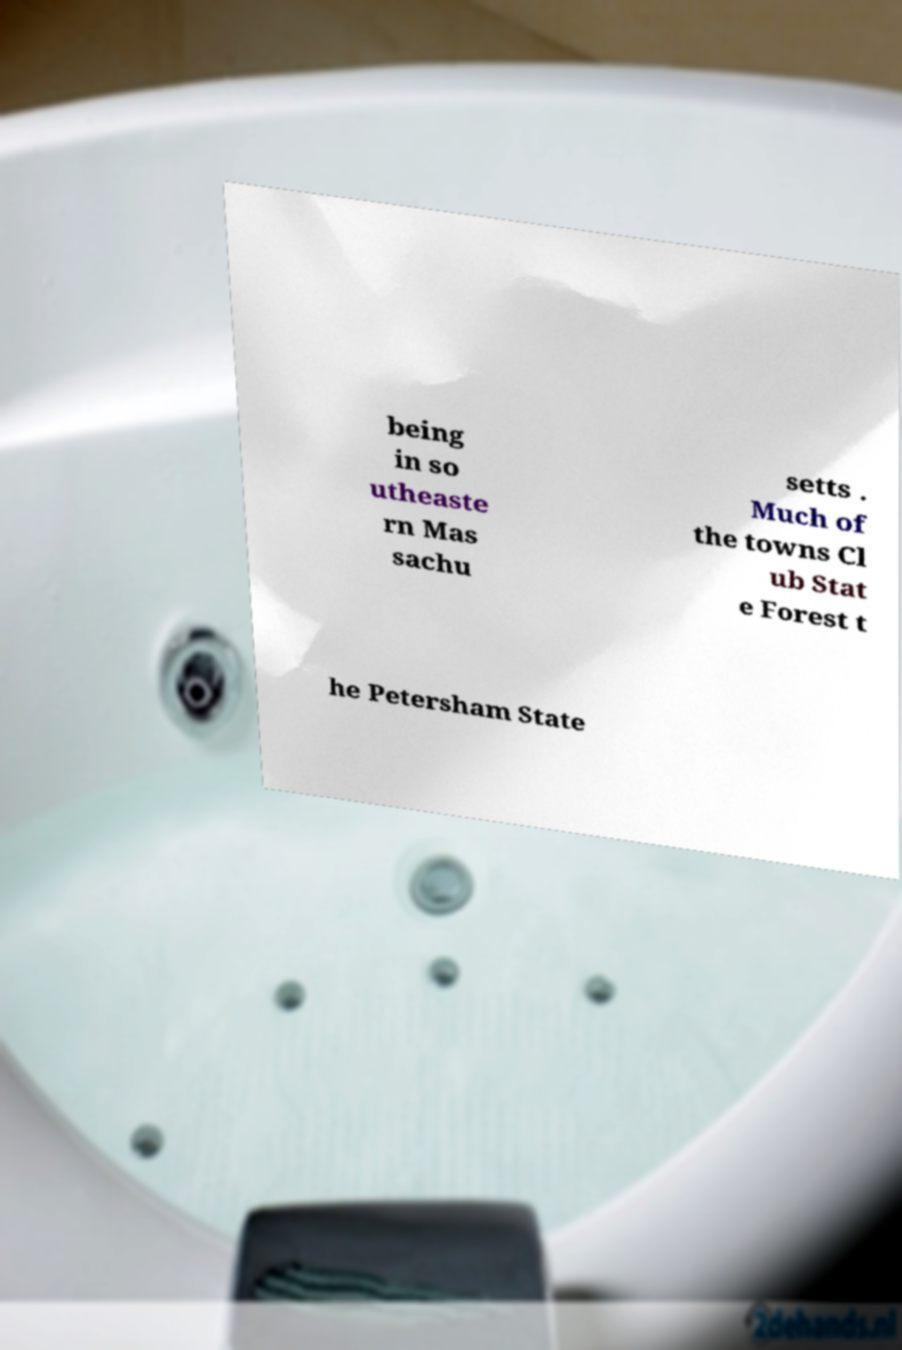There's text embedded in this image that I need extracted. Can you transcribe it verbatim? being in so utheaste rn Mas sachu setts . Much of the towns Cl ub Stat e Forest t he Petersham State 